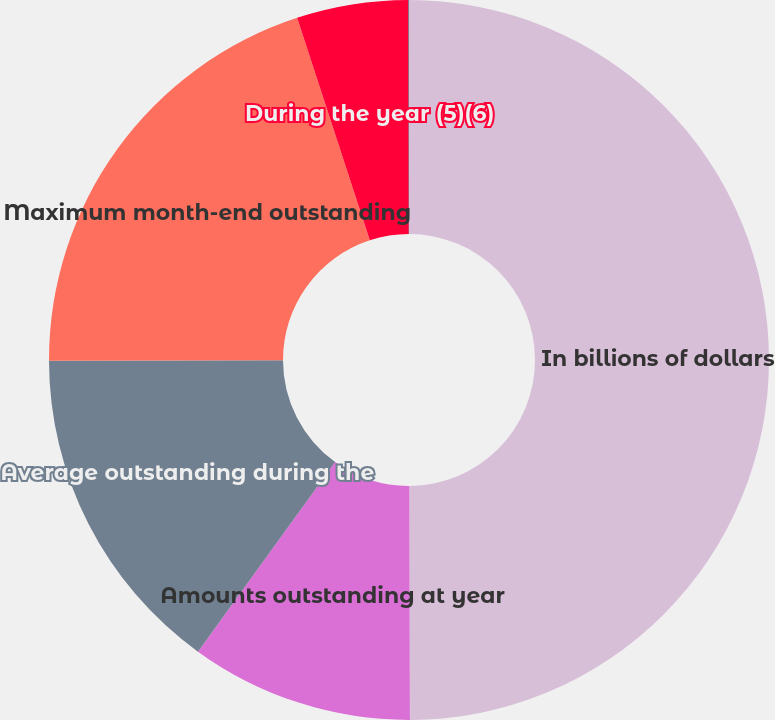Convert chart. <chart><loc_0><loc_0><loc_500><loc_500><pie_chart><fcel>In billions of dollars<fcel>Amounts outstanding at year<fcel>Average outstanding during the<fcel>Maximum month-end outstanding<fcel>During the year (5)(6)<fcel>At year end (7)<nl><fcel>49.96%<fcel>10.01%<fcel>15.0%<fcel>20.0%<fcel>5.01%<fcel>0.02%<nl></chart> 